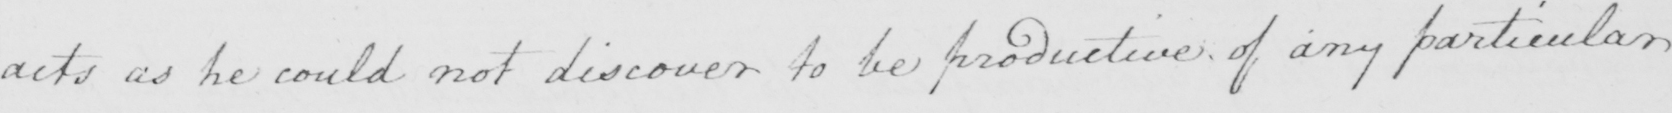Can you read and transcribe this handwriting? acts as he could not discover to be productive of any particular 